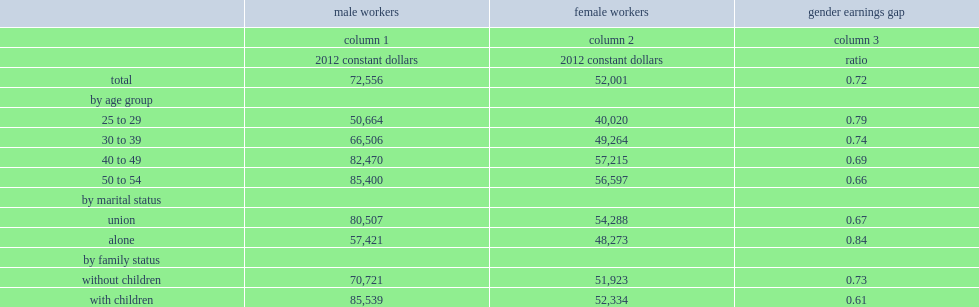How many dollars of mean earnings on the main job for an individual who earned at least the minimum threshold for male workers? 72556.0. How many dollars of mean earnings on the main job for an individual who earned at least the minimum threshold for female workers? 52001.0. 